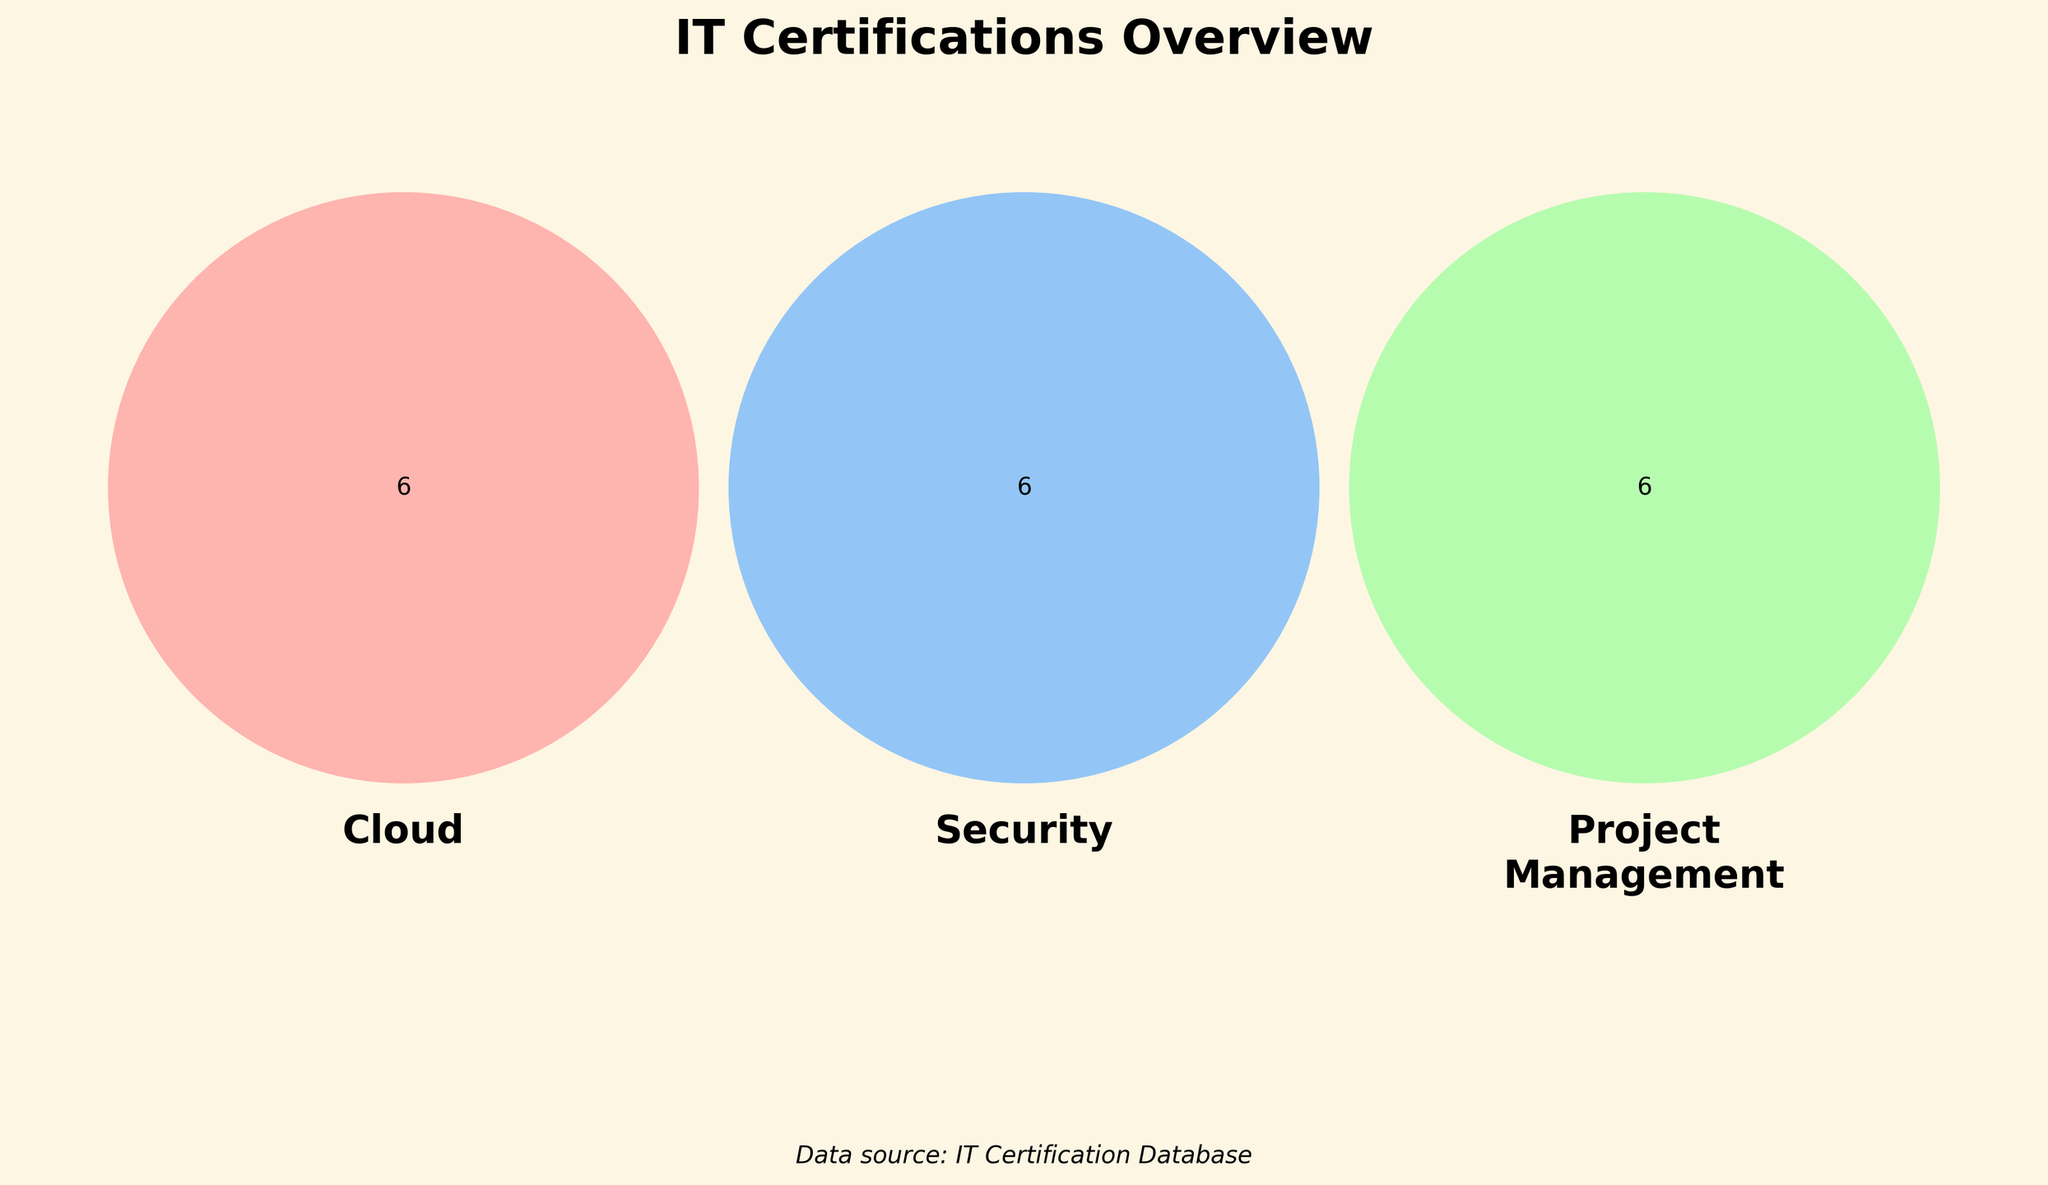What are the main certification categories shown? The figure shows a Venn diagram with three main certifications highlighted in the title: Cloud, Security, and Project Management.
Answer: Cloud, Security, Project Management How many unique certifications are listed in the Security category? Count the unique certifications within the Security circle in the Venn diagram.
Answer: 7 Which color represents the Cloud category? Look at the color assigned to the Cloud section of the Venn diagram.
Answer: Pink (#FF9999) Are there any certifications that overlap between all three categories? Check the center of the Venn diagram where all three circles intersect.
Answer: No How many certifications are common between Cloud and Project Management but not Security? Look at the section where the circles for Cloud and Project Management intersect, excluding the Security circle.
Answer: 0 Which category has a certification that includes "Azure"? Check the labels within each category for any certifications that mention "Azure."
Answer: Cloud Is there any certification listed under Security that also appears in Cloud or Project Management? Check for any overlapping sections between Security and the other two categories.
Answer: No Which category shares the most certifications with Security? Compare the overlapping sections between Cloud-Security and Project Management-Security.
Answer: Project Management List any certifications exclusive to the Cloud category. Identify the unique section of the Cloud circle without any overlaps.
Answer: AWS Certified Solutions Architect, Azure Administrator, Google Cloud Professional, Cloud+, AWS Certified DevOps Engineer How many total certifications are shown in all three categories combined? Count all the unique certifications in the Venn diagram across all categories, ensuring not to double-count overlapping ones.
Answer: 18 